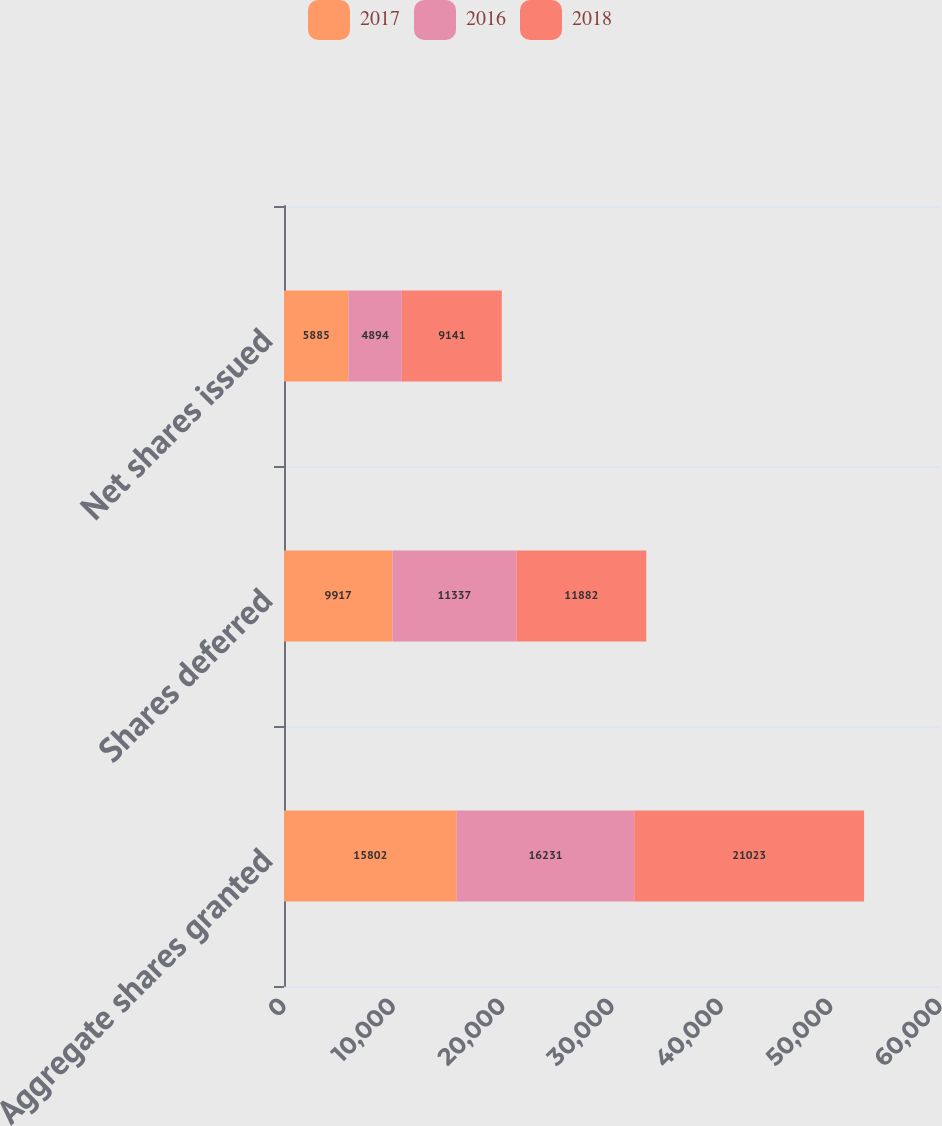Convert chart to OTSL. <chart><loc_0><loc_0><loc_500><loc_500><stacked_bar_chart><ecel><fcel>Aggregate shares granted<fcel>Shares deferred<fcel>Net shares issued<nl><fcel>2017<fcel>15802<fcel>9917<fcel>5885<nl><fcel>2016<fcel>16231<fcel>11337<fcel>4894<nl><fcel>2018<fcel>21023<fcel>11882<fcel>9141<nl></chart> 